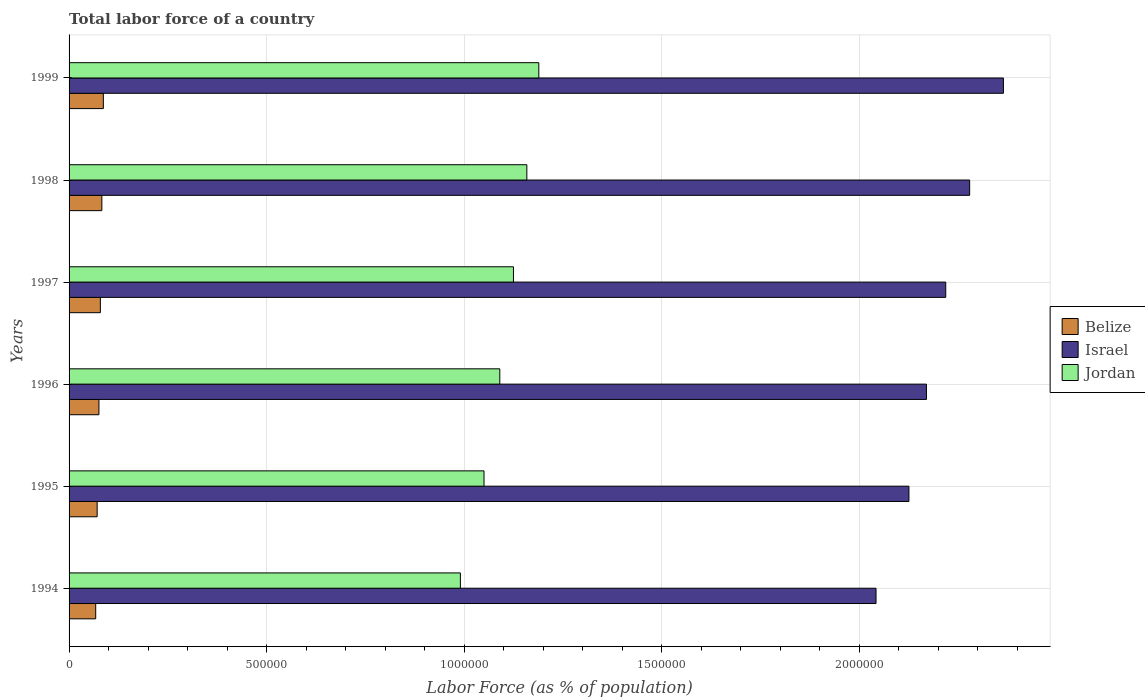Are the number of bars per tick equal to the number of legend labels?
Give a very brief answer. Yes. How many bars are there on the 4th tick from the top?
Your answer should be very brief. 3. What is the percentage of labor force in Jordan in 1994?
Keep it short and to the point. 9.90e+05. Across all years, what is the maximum percentage of labor force in Israel?
Provide a short and direct response. 2.36e+06. Across all years, what is the minimum percentage of labor force in Jordan?
Your answer should be very brief. 9.90e+05. In which year was the percentage of labor force in Belize maximum?
Your response must be concise. 1999. What is the total percentage of labor force in Jordan in the graph?
Ensure brevity in your answer.  6.60e+06. What is the difference between the percentage of labor force in Belize in 1995 and that in 1997?
Ensure brevity in your answer.  -8074. What is the difference between the percentage of labor force in Israel in 1996 and the percentage of labor force in Jordan in 1999?
Your answer should be compact. 9.81e+05. What is the average percentage of labor force in Israel per year?
Offer a very short reply. 2.20e+06. In the year 1998, what is the difference between the percentage of labor force in Israel and percentage of labor force in Jordan?
Your answer should be very brief. 1.12e+06. What is the ratio of the percentage of labor force in Jordan in 1994 to that in 1997?
Provide a succinct answer. 0.88. Is the percentage of labor force in Jordan in 1995 less than that in 1999?
Your answer should be compact. Yes. Is the difference between the percentage of labor force in Israel in 1995 and 1999 greater than the difference between the percentage of labor force in Jordan in 1995 and 1999?
Make the answer very short. No. What is the difference between the highest and the second highest percentage of labor force in Israel?
Ensure brevity in your answer.  8.54e+04. What is the difference between the highest and the lowest percentage of labor force in Israel?
Your answer should be very brief. 3.22e+05. In how many years, is the percentage of labor force in Israel greater than the average percentage of labor force in Israel taken over all years?
Provide a short and direct response. 3. Is the sum of the percentage of labor force in Jordan in 1994 and 1997 greater than the maximum percentage of labor force in Israel across all years?
Provide a short and direct response. No. What does the 3rd bar from the top in 1998 represents?
Keep it short and to the point. Belize. What does the 1st bar from the bottom in 1996 represents?
Ensure brevity in your answer.  Belize. Is it the case that in every year, the sum of the percentage of labor force in Jordan and percentage of labor force in Belize is greater than the percentage of labor force in Israel?
Keep it short and to the point. No. How many years are there in the graph?
Your answer should be compact. 6. What is the difference between two consecutive major ticks on the X-axis?
Your answer should be compact. 5.00e+05. Does the graph contain grids?
Provide a succinct answer. Yes. How many legend labels are there?
Give a very brief answer. 3. What is the title of the graph?
Your answer should be compact. Total labor force of a country. What is the label or title of the X-axis?
Your response must be concise. Labor Force (as % of population). What is the Labor Force (as % of population) of Belize in 1994?
Provide a succinct answer. 6.74e+04. What is the Labor Force (as % of population) of Israel in 1994?
Your answer should be compact. 2.04e+06. What is the Labor Force (as % of population) of Jordan in 1994?
Keep it short and to the point. 9.90e+05. What is the Labor Force (as % of population) in Belize in 1995?
Your answer should be very brief. 7.11e+04. What is the Labor Force (as % of population) in Israel in 1995?
Your response must be concise. 2.13e+06. What is the Labor Force (as % of population) in Jordan in 1995?
Provide a short and direct response. 1.05e+06. What is the Labor Force (as % of population) of Belize in 1996?
Your answer should be compact. 7.56e+04. What is the Labor Force (as % of population) in Israel in 1996?
Make the answer very short. 2.17e+06. What is the Labor Force (as % of population) in Jordan in 1996?
Provide a short and direct response. 1.09e+06. What is the Labor Force (as % of population) of Belize in 1997?
Keep it short and to the point. 7.92e+04. What is the Labor Force (as % of population) in Israel in 1997?
Offer a terse response. 2.22e+06. What is the Labor Force (as % of population) of Jordan in 1997?
Offer a very short reply. 1.12e+06. What is the Labor Force (as % of population) in Belize in 1998?
Your answer should be very brief. 8.30e+04. What is the Labor Force (as % of population) in Israel in 1998?
Keep it short and to the point. 2.28e+06. What is the Labor Force (as % of population) of Jordan in 1998?
Offer a very short reply. 1.16e+06. What is the Labor Force (as % of population) in Belize in 1999?
Keep it short and to the point. 8.68e+04. What is the Labor Force (as % of population) in Israel in 1999?
Offer a very short reply. 2.36e+06. What is the Labor Force (as % of population) in Jordan in 1999?
Keep it short and to the point. 1.19e+06. Across all years, what is the maximum Labor Force (as % of population) of Belize?
Keep it short and to the point. 8.68e+04. Across all years, what is the maximum Labor Force (as % of population) of Israel?
Your answer should be very brief. 2.36e+06. Across all years, what is the maximum Labor Force (as % of population) of Jordan?
Make the answer very short. 1.19e+06. Across all years, what is the minimum Labor Force (as % of population) in Belize?
Give a very brief answer. 6.74e+04. Across all years, what is the minimum Labor Force (as % of population) in Israel?
Provide a succinct answer. 2.04e+06. Across all years, what is the minimum Labor Force (as % of population) in Jordan?
Your answer should be compact. 9.90e+05. What is the total Labor Force (as % of population) in Belize in the graph?
Your answer should be very brief. 4.63e+05. What is the total Labor Force (as % of population) in Israel in the graph?
Give a very brief answer. 1.32e+07. What is the total Labor Force (as % of population) of Jordan in the graph?
Make the answer very short. 6.60e+06. What is the difference between the Labor Force (as % of population) in Belize in 1994 and that in 1995?
Ensure brevity in your answer.  -3683. What is the difference between the Labor Force (as % of population) of Israel in 1994 and that in 1995?
Give a very brief answer. -8.33e+04. What is the difference between the Labor Force (as % of population) in Jordan in 1994 and that in 1995?
Give a very brief answer. -5.98e+04. What is the difference between the Labor Force (as % of population) of Belize in 1994 and that in 1996?
Keep it short and to the point. -8165. What is the difference between the Labor Force (as % of population) in Israel in 1994 and that in 1996?
Keep it short and to the point. -1.28e+05. What is the difference between the Labor Force (as % of population) in Jordan in 1994 and that in 1996?
Your response must be concise. -9.98e+04. What is the difference between the Labor Force (as % of population) in Belize in 1994 and that in 1997?
Ensure brevity in your answer.  -1.18e+04. What is the difference between the Labor Force (as % of population) in Israel in 1994 and that in 1997?
Provide a succinct answer. -1.76e+05. What is the difference between the Labor Force (as % of population) in Jordan in 1994 and that in 1997?
Give a very brief answer. -1.34e+05. What is the difference between the Labor Force (as % of population) in Belize in 1994 and that in 1998?
Give a very brief answer. -1.56e+04. What is the difference between the Labor Force (as % of population) of Israel in 1994 and that in 1998?
Ensure brevity in your answer.  -2.37e+05. What is the difference between the Labor Force (as % of population) of Jordan in 1994 and that in 1998?
Your answer should be very brief. -1.68e+05. What is the difference between the Labor Force (as % of population) of Belize in 1994 and that in 1999?
Make the answer very short. -1.93e+04. What is the difference between the Labor Force (as % of population) in Israel in 1994 and that in 1999?
Your answer should be compact. -3.22e+05. What is the difference between the Labor Force (as % of population) of Jordan in 1994 and that in 1999?
Offer a terse response. -1.99e+05. What is the difference between the Labor Force (as % of population) in Belize in 1995 and that in 1996?
Your response must be concise. -4482. What is the difference between the Labor Force (as % of population) of Israel in 1995 and that in 1996?
Offer a terse response. -4.44e+04. What is the difference between the Labor Force (as % of population) in Jordan in 1995 and that in 1996?
Your answer should be compact. -3.99e+04. What is the difference between the Labor Force (as % of population) of Belize in 1995 and that in 1997?
Give a very brief answer. -8074. What is the difference between the Labor Force (as % of population) in Israel in 1995 and that in 1997?
Keep it short and to the point. -9.31e+04. What is the difference between the Labor Force (as % of population) in Jordan in 1995 and that in 1997?
Provide a succinct answer. -7.45e+04. What is the difference between the Labor Force (as % of population) of Belize in 1995 and that in 1998?
Keep it short and to the point. -1.19e+04. What is the difference between the Labor Force (as % of population) of Israel in 1995 and that in 1998?
Offer a very short reply. -1.54e+05. What is the difference between the Labor Force (as % of population) in Jordan in 1995 and that in 1998?
Offer a terse response. -1.08e+05. What is the difference between the Labor Force (as % of population) in Belize in 1995 and that in 1999?
Your answer should be compact. -1.57e+04. What is the difference between the Labor Force (as % of population) of Israel in 1995 and that in 1999?
Offer a very short reply. -2.39e+05. What is the difference between the Labor Force (as % of population) of Jordan in 1995 and that in 1999?
Offer a terse response. -1.39e+05. What is the difference between the Labor Force (as % of population) in Belize in 1996 and that in 1997?
Make the answer very short. -3592. What is the difference between the Labor Force (as % of population) of Israel in 1996 and that in 1997?
Your response must be concise. -4.88e+04. What is the difference between the Labor Force (as % of population) in Jordan in 1996 and that in 1997?
Offer a very short reply. -3.46e+04. What is the difference between the Labor Force (as % of population) in Belize in 1996 and that in 1998?
Offer a very short reply. -7426. What is the difference between the Labor Force (as % of population) of Israel in 1996 and that in 1998?
Make the answer very short. -1.09e+05. What is the difference between the Labor Force (as % of population) of Jordan in 1996 and that in 1998?
Make the answer very short. -6.84e+04. What is the difference between the Labor Force (as % of population) of Belize in 1996 and that in 1999?
Give a very brief answer. -1.12e+04. What is the difference between the Labor Force (as % of population) in Israel in 1996 and that in 1999?
Keep it short and to the point. -1.95e+05. What is the difference between the Labor Force (as % of population) in Jordan in 1996 and that in 1999?
Keep it short and to the point. -9.87e+04. What is the difference between the Labor Force (as % of population) of Belize in 1997 and that in 1998?
Your answer should be very brief. -3834. What is the difference between the Labor Force (as % of population) in Israel in 1997 and that in 1998?
Give a very brief answer. -6.05e+04. What is the difference between the Labor Force (as % of population) of Jordan in 1997 and that in 1998?
Your answer should be compact. -3.39e+04. What is the difference between the Labor Force (as % of population) of Belize in 1997 and that in 1999?
Provide a succinct answer. -7586. What is the difference between the Labor Force (as % of population) of Israel in 1997 and that in 1999?
Ensure brevity in your answer.  -1.46e+05. What is the difference between the Labor Force (as % of population) of Jordan in 1997 and that in 1999?
Provide a succinct answer. -6.42e+04. What is the difference between the Labor Force (as % of population) of Belize in 1998 and that in 1999?
Your response must be concise. -3752. What is the difference between the Labor Force (as % of population) in Israel in 1998 and that in 1999?
Ensure brevity in your answer.  -8.54e+04. What is the difference between the Labor Force (as % of population) in Jordan in 1998 and that in 1999?
Offer a terse response. -3.03e+04. What is the difference between the Labor Force (as % of population) of Belize in 1994 and the Labor Force (as % of population) of Israel in 1995?
Give a very brief answer. -2.06e+06. What is the difference between the Labor Force (as % of population) in Belize in 1994 and the Labor Force (as % of population) in Jordan in 1995?
Provide a succinct answer. -9.83e+05. What is the difference between the Labor Force (as % of population) of Israel in 1994 and the Labor Force (as % of population) of Jordan in 1995?
Your answer should be very brief. 9.92e+05. What is the difference between the Labor Force (as % of population) in Belize in 1994 and the Labor Force (as % of population) in Israel in 1996?
Offer a very short reply. -2.10e+06. What is the difference between the Labor Force (as % of population) in Belize in 1994 and the Labor Force (as % of population) in Jordan in 1996?
Your response must be concise. -1.02e+06. What is the difference between the Labor Force (as % of population) of Israel in 1994 and the Labor Force (as % of population) of Jordan in 1996?
Your answer should be very brief. 9.52e+05. What is the difference between the Labor Force (as % of population) in Belize in 1994 and the Labor Force (as % of population) in Israel in 1997?
Offer a terse response. -2.15e+06. What is the difference between the Labor Force (as % of population) in Belize in 1994 and the Labor Force (as % of population) in Jordan in 1997?
Ensure brevity in your answer.  -1.06e+06. What is the difference between the Labor Force (as % of population) in Israel in 1994 and the Labor Force (as % of population) in Jordan in 1997?
Keep it short and to the point. 9.18e+05. What is the difference between the Labor Force (as % of population) of Belize in 1994 and the Labor Force (as % of population) of Israel in 1998?
Ensure brevity in your answer.  -2.21e+06. What is the difference between the Labor Force (as % of population) in Belize in 1994 and the Labor Force (as % of population) in Jordan in 1998?
Provide a short and direct response. -1.09e+06. What is the difference between the Labor Force (as % of population) in Israel in 1994 and the Labor Force (as % of population) in Jordan in 1998?
Keep it short and to the point. 8.84e+05. What is the difference between the Labor Force (as % of population) of Belize in 1994 and the Labor Force (as % of population) of Israel in 1999?
Offer a very short reply. -2.30e+06. What is the difference between the Labor Force (as % of population) of Belize in 1994 and the Labor Force (as % of population) of Jordan in 1999?
Make the answer very short. -1.12e+06. What is the difference between the Labor Force (as % of population) of Israel in 1994 and the Labor Force (as % of population) of Jordan in 1999?
Offer a very short reply. 8.53e+05. What is the difference between the Labor Force (as % of population) in Belize in 1995 and the Labor Force (as % of population) in Israel in 1996?
Keep it short and to the point. -2.10e+06. What is the difference between the Labor Force (as % of population) of Belize in 1995 and the Labor Force (as % of population) of Jordan in 1996?
Your answer should be very brief. -1.02e+06. What is the difference between the Labor Force (as % of population) of Israel in 1995 and the Labor Force (as % of population) of Jordan in 1996?
Provide a succinct answer. 1.04e+06. What is the difference between the Labor Force (as % of population) of Belize in 1995 and the Labor Force (as % of population) of Israel in 1997?
Offer a terse response. -2.15e+06. What is the difference between the Labor Force (as % of population) in Belize in 1995 and the Labor Force (as % of population) in Jordan in 1997?
Give a very brief answer. -1.05e+06. What is the difference between the Labor Force (as % of population) of Israel in 1995 and the Labor Force (as % of population) of Jordan in 1997?
Your answer should be very brief. 1.00e+06. What is the difference between the Labor Force (as % of population) in Belize in 1995 and the Labor Force (as % of population) in Israel in 1998?
Provide a short and direct response. -2.21e+06. What is the difference between the Labor Force (as % of population) in Belize in 1995 and the Labor Force (as % of population) in Jordan in 1998?
Provide a short and direct response. -1.09e+06. What is the difference between the Labor Force (as % of population) of Israel in 1995 and the Labor Force (as % of population) of Jordan in 1998?
Offer a terse response. 9.67e+05. What is the difference between the Labor Force (as % of population) of Belize in 1995 and the Labor Force (as % of population) of Israel in 1999?
Your answer should be very brief. -2.29e+06. What is the difference between the Labor Force (as % of population) of Belize in 1995 and the Labor Force (as % of population) of Jordan in 1999?
Make the answer very short. -1.12e+06. What is the difference between the Labor Force (as % of population) in Israel in 1995 and the Labor Force (as % of population) in Jordan in 1999?
Give a very brief answer. 9.37e+05. What is the difference between the Labor Force (as % of population) of Belize in 1996 and the Labor Force (as % of population) of Israel in 1997?
Give a very brief answer. -2.14e+06. What is the difference between the Labor Force (as % of population) of Belize in 1996 and the Labor Force (as % of population) of Jordan in 1997?
Keep it short and to the point. -1.05e+06. What is the difference between the Labor Force (as % of population) of Israel in 1996 and the Labor Force (as % of population) of Jordan in 1997?
Offer a terse response. 1.05e+06. What is the difference between the Labor Force (as % of population) of Belize in 1996 and the Labor Force (as % of population) of Israel in 1998?
Your response must be concise. -2.20e+06. What is the difference between the Labor Force (as % of population) in Belize in 1996 and the Labor Force (as % of population) in Jordan in 1998?
Provide a succinct answer. -1.08e+06. What is the difference between the Labor Force (as % of population) of Israel in 1996 and the Labor Force (as % of population) of Jordan in 1998?
Offer a very short reply. 1.01e+06. What is the difference between the Labor Force (as % of population) in Belize in 1996 and the Labor Force (as % of population) in Israel in 1999?
Provide a short and direct response. -2.29e+06. What is the difference between the Labor Force (as % of population) in Belize in 1996 and the Labor Force (as % of population) in Jordan in 1999?
Your response must be concise. -1.11e+06. What is the difference between the Labor Force (as % of population) in Israel in 1996 and the Labor Force (as % of population) in Jordan in 1999?
Your answer should be compact. 9.81e+05. What is the difference between the Labor Force (as % of population) of Belize in 1997 and the Labor Force (as % of population) of Israel in 1998?
Give a very brief answer. -2.20e+06. What is the difference between the Labor Force (as % of population) of Belize in 1997 and the Labor Force (as % of population) of Jordan in 1998?
Your answer should be very brief. -1.08e+06. What is the difference between the Labor Force (as % of population) of Israel in 1997 and the Labor Force (as % of population) of Jordan in 1998?
Your answer should be compact. 1.06e+06. What is the difference between the Labor Force (as % of population) in Belize in 1997 and the Labor Force (as % of population) in Israel in 1999?
Your answer should be very brief. -2.29e+06. What is the difference between the Labor Force (as % of population) of Belize in 1997 and the Labor Force (as % of population) of Jordan in 1999?
Ensure brevity in your answer.  -1.11e+06. What is the difference between the Labor Force (as % of population) in Israel in 1997 and the Labor Force (as % of population) in Jordan in 1999?
Provide a succinct answer. 1.03e+06. What is the difference between the Labor Force (as % of population) in Belize in 1998 and the Labor Force (as % of population) in Israel in 1999?
Provide a short and direct response. -2.28e+06. What is the difference between the Labor Force (as % of population) of Belize in 1998 and the Labor Force (as % of population) of Jordan in 1999?
Offer a terse response. -1.11e+06. What is the difference between the Labor Force (as % of population) in Israel in 1998 and the Labor Force (as % of population) in Jordan in 1999?
Make the answer very short. 1.09e+06. What is the average Labor Force (as % of population) in Belize per year?
Give a very brief answer. 7.72e+04. What is the average Labor Force (as % of population) in Israel per year?
Keep it short and to the point. 2.20e+06. What is the average Labor Force (as % of population) in Jordan per year?
Ensure brevity in your answer.  1.10e+06. In the year 1994, what is the difference between the Labor Force (as % of population) of Belize and Labor Force (as % of population) of Israel?
Provide a short and direct response. -1.97e+06. In the year 1994, what is the difference between the Labor Force (as % of population) in Belize and Labor Force (as % of population) in Jordan?
Provide a succinct answer. -9.23e+05. In the year 1994, what is the difference between the Labor Force (as % of population) of Israel and Labor Force (as % of population) of Jordan?
Provide a short and direct response. 1.05e+06. In the year 1995, what is the difference between the Labor Force (as % of population) of Belize and Labor Force (as % of population) of Israel?
Your answer should be very brief. -2.05e+06. In the year 1995, what is the difference between the Labor Force (as % of population) in Belize and Labor Force (as % of population) in Jordan?
Offer a terse response. -9.79e+05. In the year 1995, what is the difference between the Labor Force (as % of population) in Israel and Labor Force (as % of population) in Jordan?
Your response must be concise. 1.08e+06. In the year 1996, what is the difference between the Labor Force (as % of population) in Belize and Labor Force (as % of population) in Israel?
Make the answer very short. -2.09e+06. In the year 1996, what is the difference between the Labor Force (as % of population) in Belize and Labor Force (as % of population) in Jordan?
Ensure brevity in your answer.  -1.01e+06. In the year 1996, what is the difference between the Labor Force (as % of population) of Israel and Labor Force (as % of population) of Jordan?
Your answer should be very brief. 1.08e+06. In the year 1997, what is the difference between the Labor Force (as % of population) of Belize and Labor Force (as % of population) of Israel?
Ensure brevity in your answer.  -2.14e+06. In the year 1997, what is the difference between the Labor Force (as % of population) in Belize and Labor Force (as % of population) in Jordan?
Offer a terse response. -1.05e+06. In the year 1997, what is the difference between the Labor Force (as % of population) in Israel and Labor Force (as % of population) in Jordan?
Make the answer very short. 1.09e+06. In the year 1998, what is the difference between the Labor Force (as % of population) of Belize and Labor Force (as % of population) of Israel?
Your answer should be very brief. -2.20e+06. In the year 1998, what is the difference between the Labor Force (as % of population) of Belize and Labor Force (as % of population) of Jordan?
Ensure brevity in your answer.  -1.08e+06. In the year 1998, what is the difference between the Labor Force (as % of population) of Israel and Labor Force (as % of population) of Jordan?
Offer a very short reply. 1.12e+06. In the year 1999, what is the difference between the Labor Force (as % of population) in Belize and Labor Force (as % of population) in Israel?
Your answer should be compact. -2.28e+06. In the year 1999, what is the difference between the Labor Force (as % of population) in Belize and Labor Force (as % of population) in Jordan?
Your answer should be very brief. -1.10e+06. In the year 1999, what is the difference between the Labor Force (as % of population) of Israel and Labor Force (as % of population) of Jordan?
Give a very brief answer. 1.18e+06. What is the ratio of the Labor Force (as % of population) of Belize in 1994 to that in 1995?
Provide a succinct answer. 0.95. What is the ratio of the Labor Force (as % of population) of Israel in 1994 to that in 1995?
Offer a terse response. 0.96. What is the ratio of the Labor Force (as % of population) in Jordan in 1994 to that in 1995?
Offer a very short reply. 0.94. What is the ratio of the Labor Force (as % of population) of Belize in 1994 to that in 1996?
Give a very brief answer. 0.89. What is the ratio of the Labor Force (as % of population) of Jordan in 1994 to that in 1996?
Give a very brief answer. 0.91. What is the ratio of the Labor Force (as % of population) in Belize in 1994 to that in 1997?
Provide a short and direct response. 0.85. What is the ratio of the Labor Force (as % of population) in Israel in 1994 to that in 1997?
Give a very brief answer. 0.92. What is the ratio of the Labor Force (as % of population) in Jordan in 1994 to that in 1997?
Your answer should be very brief. 0.88. What is the ratio of the Labor Force (as % of population) of Belize in 1994 to that in 1998?
Provide a succinct answer. 0.81. What is the ratio of the Labor Force (as % of population) of Israel in 1994 to that in 1998?
Your response must be concise. 0.9. What is the ratio of the Labor Force (as % of population) in Jordan in 1994 to that in 1998?
Offer a very short reply. 0.85. What is the ratio of the Labor Force (as % of population) in Belize in 1994 to that in 1999?
Provide a short and direct response. 0.78. What is the ratio of the Labor Force (as % of population) in Israel in 1994 to that in 1999?
Give a very brief answer. 0.86. What is the ratio of the Labor Force (as % of population) of Jordan in 1994 to that in 1999?
Make the answer very short. 0.83. What is the ratio of the Labor Force (as % of population) in Belize in 1995 to that in 1996?
Make the answer very short. 0.94. What is the ratio of the Labor Force (as % of population) in Israel in 1995 to that in 1996?
Keep it short and to the point. 0.98. What is the ratio of the Labor Force (as % of population) in Jordan in 1995 to that in 1996?
Your answer should be very brief. 0.96. What is the ratio of the Labor Force (as % of population) in Belize in 1995 to that in 1997?
Make the answer very short. 0.9. What is the ratio of the Labor Force (as % of population) of Israel in 1995 to that in 1997?
Provide a succinct answer. 0.96. What is the ratio of the Labor Force (as % of population) of Jordan in 1995 to that in 1997?
Make the answer very short. 0.93. What is the ratio of the Labor Force (as % of population) in Belize in 1995 to that in 1998?
Make the answer very short. 0.86. What is the ratio of the Labor Force (as % of population) of Israel in 1995 to that in 1998?
Offer a terse response. 0.93. What is the ratio of the Labor Force (as % of population) in Jordan in 1995 to that in 1998?
Give a very brief answer. 0.91. What is the ratio of the Labor Force (as % of population) of Belize in 1995 to that in 1999?
Your answer should be compact. 0.82. What is the ratio of the Labor Force (as % of population) of Israel in 1995 to that in 1999?
Your response must be concise. 0.9. What is the ratio of the Labor Force (as % of population) of Jordan in 1995 to that in 1999?
Provide a short and direct response. 0.88. What is the ratio of the Labor Force (as % of population) of Belize in 1996 to that in 1997?
Your answer should be compact. 0.95. What is the ratio of the Labor Force (as % of population) of Israel in 1996 to that in 1997?
Your response must be concise. 0.98. What is the ratio of the Labor Force (as % of population) in Jordan in 1996 to that in 1997?
Give a very brief answer. 0.97. What is the ratio of the Labor Force (as % of population) of Belize in 1996 to that in 1998?
Your response must be concise. 0.91. What is the ratio of the Labor Force (as % of population) in Israel in 1996 to that in 1998?
Provide a short and direct response. 0.95. What is the ratio of the Labor Force (as % of population) in Jordan in 1996 to that in 1998?
Your answer should be compact. 0.94. What is the ratio of the Labor Force (as % of population) in Belize in 1996 to that in 1999?
Offer a very short reply. 0.87. What is the ratio of the Labor Force (as % of population) in Israel in 1996 to that in 1999?
Make the answer very short. 0.92. What is the ratio of the Labor Force (as % of population) of Jordan in 1996 to that in 1999?
Offer a terse response. 0.92. What is the ratio of the Labor Force (as % of population) of Belize in 1997 to that in 1998?
Your response must be concise. 0.95. What is the ratio of the Labor Force (as % of population) of Israel in 1997 to that in 1998?
Make the answer very short. 0.97. What is the ratio of the Labor Force (as % of population) of Jordan in 1997 to that in 1998?
Your answer should be very brief. 0.97. What is the ratio of the Labor Force (as % of population) of Belize in 1997 to that in 1999?
Keep it short and to the point. 0.91. What is the ratio of the Labor Force (as % of population) of Israel in 1997 to that in 1999?
Your response must be concise. 0.94. What is the ratio of the Labor Force (as % of population) of Jordan in 1997 to that in 1999?
Make the answer very short. 0.95. What is the ratio of the Labor Force (as % of population) of Belize in 1998 to that in 1999?
Offer a terse response. 0.96. What is the ratio of the Labor Force (as % of population) in Israel in 1998 to that in 1999?
Give a very brief answer. 0.96. What is the ratio of the Labor Force (as % of population) of Jordan in 1998 to that in 1999?
Your answer should be compact. 0.97. What is the difference between the highest and the second highest Labor Force (as % of population) of Belize?
Offer a very short reply. 3752. What is the difference between the highest and the second highest Labor Force (as % of population) in Israel?
Provide a succinct answer. 8.54e+04. What is the difference between the highest and the second highest Labor Force (as % of population) of Jordan?
Keep it short and to the point. 3.03e+04. What is the difference between the highest and the lowest Labor Force (as % of population) of Belize?
Give a very brief answer. 1.93e+04. What is the difference between the highest and the lowest Labor Force (as % of population) of Israel?
Ensure brevity in your answer.  3.22e+05. What is the difference between the highest and the lowest Labor Force (as % of population) of Jordan?
Give a very brief answer. 1.99e+05. 